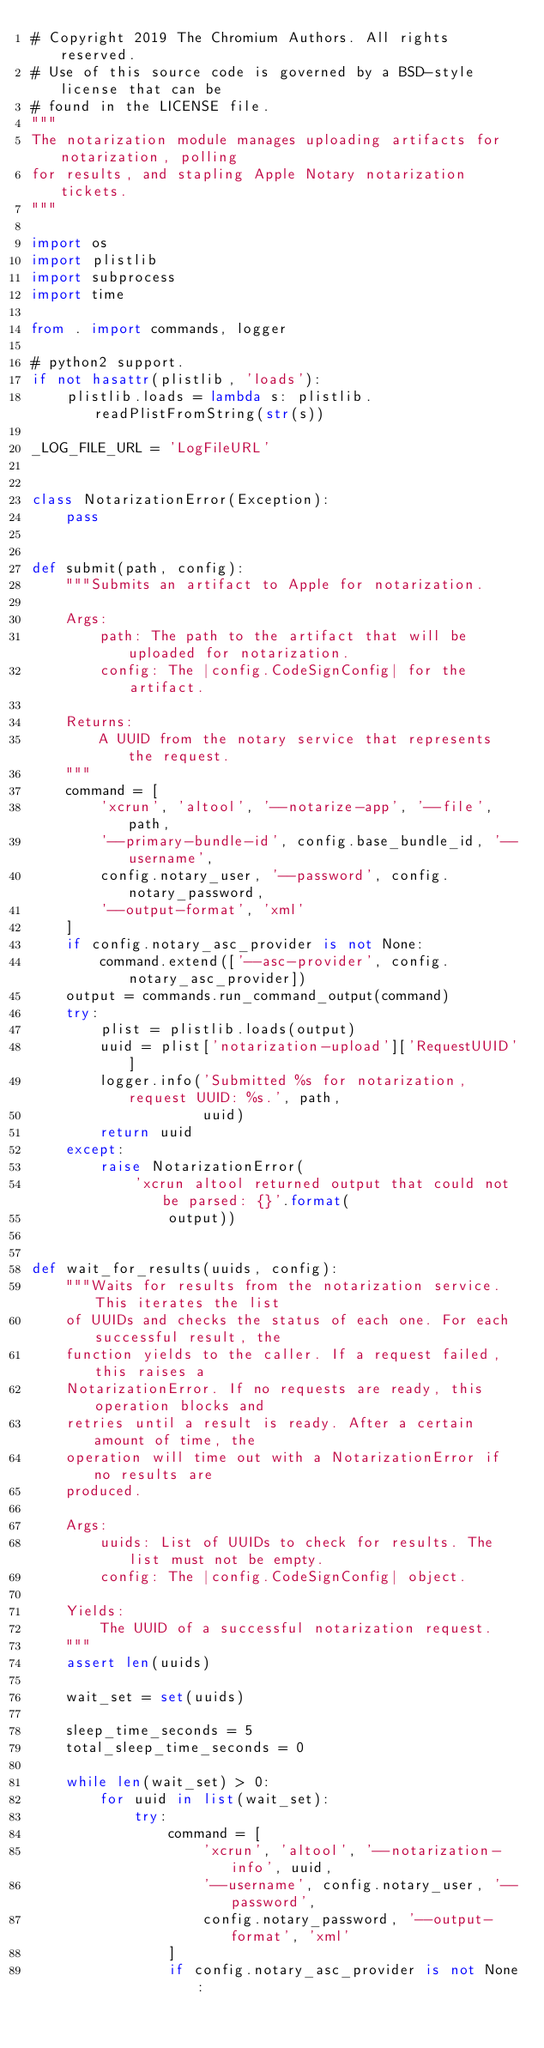<code> <loc_0><loc_0><loc_500><loc_500><_Python_># Copyright 2019 The Chromium Authors. All rights reserved.
# Use of this source code is governed by a BSD-style license that can be
# found in the LICENSE file.
"""
The notarization module manages uploading artifacts for notarization, polling
for results, and stapling Apple Notary notarization tickets.
"""

import os
import plistlib
import subprocess
import time

from . import commands, logger

# python2 support.
if not hasattr(plistlib, 'loads'):
    plistlib.loads = lambda s: plistlib.readPlistFromString(str(s))

_LOG_FILE_URL = 'LogFileURL'


class NotarizationError(Exception):
    pass


def submit(path, config):
    """Submits an artifact to Apple for notarization.

    Args:
        path: The path to the artifact that will be uploaded for notarization.
        config: The |config.CodeSignConfig| for the artifact.

    Returns:
        A UUID from the notary service that represents the request.
    """
    command = [
        'xcrun', 'altool', '--notarize-app', '--file', path,
        '--primary-bundle-id', config.base_bundle_id, '--username',
        config.notary_user, '--password', config.notary_password,
        '--output-format', 'xml'
    ]
    if config.notary_asc_provider is not None:
        command.extend(['--asc-provider', config.notary_asc_provider])
    output = commands.run_command_output(command)
    try:
        plist = plistlib.loads(output)
        uuid = plist['notarization-upload']['RequestUUID']
        logger.info('Submitted %s for notarization, request UUID: %s.', path,
                    uuid)
        return uuid
    except:
        raise NotarizationError(
            'xcrun altool returned output that could not be parsed: {}'.format(
                output))


def wait_for_results(uuids, config):
    """Waits for results from the notarization service. This iterates the list
    of UUIDs and checks the status of each one. For each successful result, the
    function yields to the caller. If a request failed, this raises a
    NotarizationError. If no requests are ready, this operation blocks and
    retries until a result is ready. After a certain amount of time, the
    operation will time out with a NotarizationError if no results are
    produced.

    Args:
        uuids: List of UUIDs to check for results. The list must not be empty.
        config: The |config.CodeSignConfig| object.

    Yields:
        The UUID of a successful notarization request.
    """
    assert len(uuids)

    wait_set = set(uuids)

    sleep_time_seconds = 5
    total_sleep_time_seconds = 0

    while len(wait_set) > 0:
        for uuid in list(wait_set):
            try:
                command = [
                    'xcrun', 'altool', '--notarization-info', uuid,
                    '--username', config.notary_user, '--password',
                    config.notary_password, '--output-format', 'xml'
                ]
                if config.notary_asc_provider is not None:</code> 